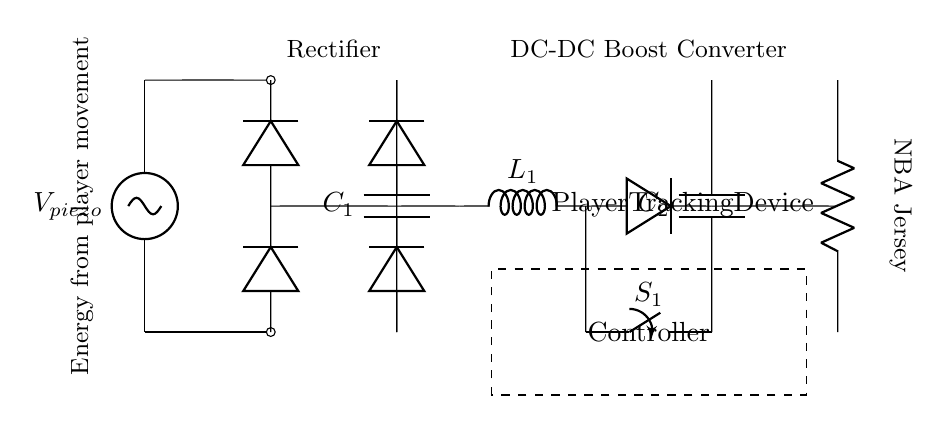What is the energy source in the circuit? The circuit uses energy harvested from player movement, indicated by the piezoelectric voltage source labeled V_piezo.
Answer: piezoelectric What type of converter is used in this energy harvesting circuit? The circuit features a DC-DC Boost converter, which steps up the voltage to the necessary levels for the load. This is represented by the diagram from the component labeled L_1.
Answer: DC-DC Boost converter What component is used to smooth the output voltage? The capacitor C_1 is used for smoothing the output voltage after the rectification process, ensuring a stable voltage supply to the DC-DC Boost converter.
Answer: C_1 How many diodes are present in the rectifier bridge? The rectifier bridge contains four diodes, typically arranged in a bridge configuration to ensure that current flows in the correct direction regardless of the input polarity.
Answer: four What function does the switch labeled S_1 serve? The switch S_1 allows control over the connection to the load (player tracking device), enabling or disabling power delivery to the load as needed based on the circuit's operation or requirements.
Answer: controls power delivery What is the load in this circuit? The load in this circuit is the Player Tracking Device, which consumes the harvested energy to function, represented by the resistor labeled Player Tracking Device.
Answer: Player Tracking Device What component is labeled as providing energy from player movement? The component providing energy from player movement is the piezoelectric voltage source, which captures and converts mechanical energy generated by the player's movements into electrical energy for the circuit.
Answer: V_piezo 